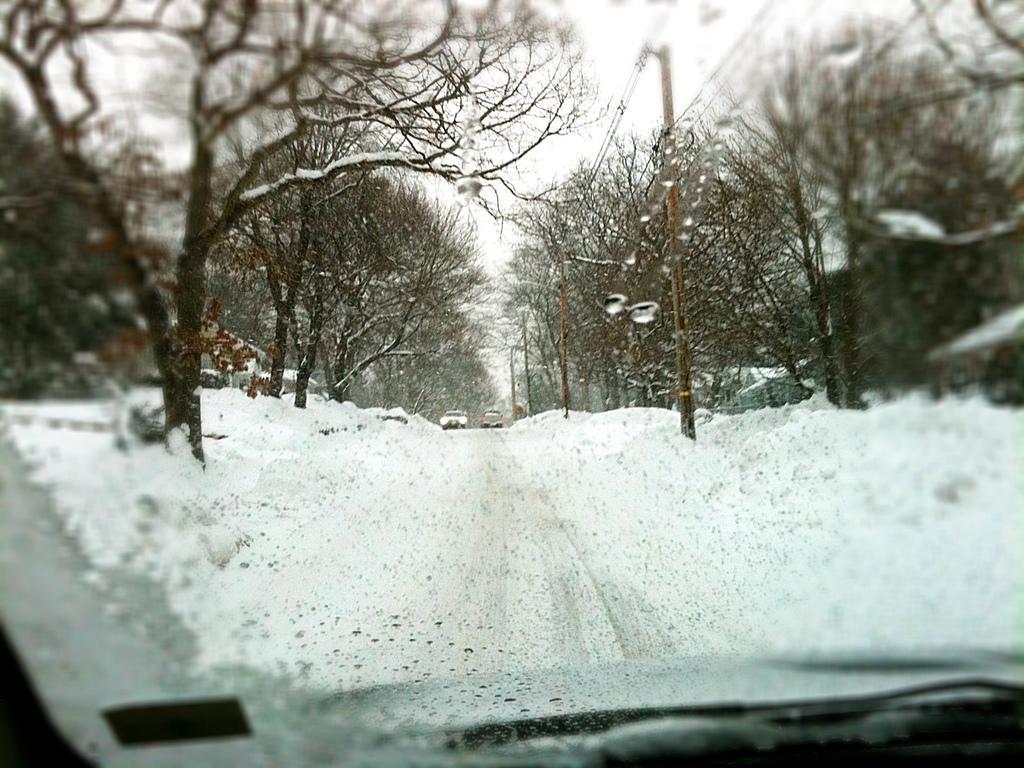In one or two sentences, can you explain what this image depicts? This is the front glass of a vehicle. Through the glass we can see snow on the ground,bare trees,vehicles,poles,wires,buildings and sky. 